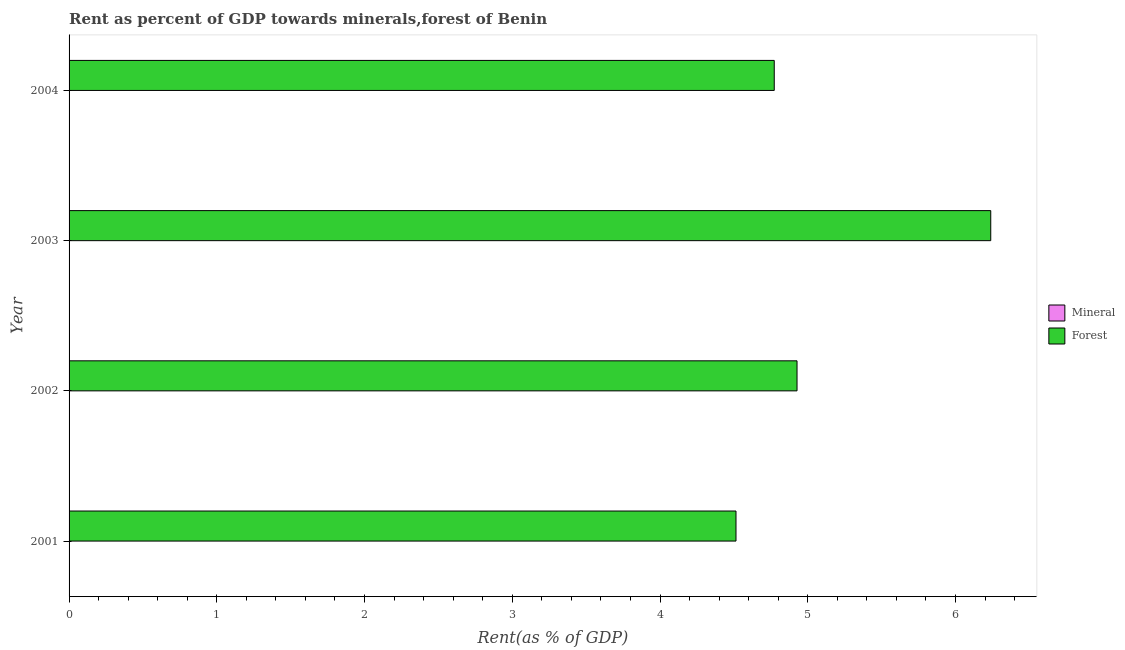How many groups of bars are there?
Provide a succinct answer. 4. Are the number of bars on each tick of the Y-axis equal?
Make the answer very short. Yes. How many bars are there on the 4th tick from the top?
Keep it short and to the point. 2. What is the label of the 2nd group of bars from the top?
Offer a very short reply. 2003. In how many cases, is the number of bars for a given year not equal to the number of legend labels?
Offer a very short reply. 0. What is the forest rent in 2004?
Your response must be concise. 4.77. Across all years, what is the maximum mineral rent?
Provide a succinct answer. 0. Across all years, what is the minimum mineral rent?
Your response must be concise. 0. In which year was the forest rent minimum?
Provide a short and direct response. 2001. What is the total forest rent in the graph?
Your response must be concise. 20.45. What is the difference between the mineral rent in 2001 and the forest rent in 2002?
Your answer should be very brief. -4.93. What is the average forest rent per year?
Provide a succinct answer. 5.11. In the year 2002, what is the difference between the forest rent and mineral rent?
Your answer should be very brief. 4.93. In how many years, is the mineral rent greater than 2 %?
Keep it short and to the point. 0. What is the ratio of the mineral rent in 2001 to that in 2004?
Your answer should be very brief. 0.07. In how many years, is the mineral rent greater than the average mineral rent taken over all years?
Your response must be concise. 2. What does the 2nd bar from the top in 2002 represents?
Your answer should be very brief. Mineral. What does the 1st bar from the bottom in 2003 represents?
Your response must be concise. Mineral. How many bars are there?
Provide a succinct answer. 8. Does the graph contain any zero values?
Give a very brief answer. No. Does the graph contain grids?
Provide a short and direct response. No. Where does the legend appear in the graph?
Offer a very short reply. Center right. What is the title of the graph?
Offer a terse response. Rent as percent of GDP towards minerals,forest of Benin. What is the label or title of the X-axis?
Make the answer very short. Rent(as % of GDP). What is the Rent(as % of GDP) of Mineral in 2001?
Your response must be concise. 0. What is the Rent(as % of GDP) of Forest in 2001?
Make the answer very short. 4.51. What is the Rent(as % of GDP) of Mineral in 2002?
Provide a succinct answer. 0. What is the Rent(as % of GDP) of Forest in 2002?
Offer a very short reply. 4.93. What is the Rent(as % of GDP) in Mineral in 2003?
Ensure brevity in your answer.  0. What is the Rent(as % of GDP) of Forest in 2003?
Your response must be concise. 6.24. What is the Rent(as % of GDP) of Mineral in 2004?
Offer a terse response. 0. What is the Rent(as % of GDP) in Forest in 2004?
Provide a succinct answer. 4.77. Across all years, what is the maximum Rent(as % of GDP) in Mineral?
Offer a very short reply. 0. Across all years, what is the maximum Rent(as % of GDP) of Forest?
Provide a short and direct response. 6.24. Across all years, what is the minimum Rent(as % of GDP) of Mineral?
Your answer should be very brief. 0. Across all years, what is the minimum Rent(as % of GDP) of Forest?
Your answer should be very brief. 4.51. What is the total Rent(as % of GDP) in Mineral in the graph?
Ensure brevity in your answer.  0. What is the total Rent(as % of GDP) of Forest in the graph?
Offer a terse response. 20.45. What is the difference between the Rent(as % of GDP) of Mineral in 2001 and that in 2002?
Ensure brevity in your answer.  -0. What is the difference between the Rent(as % of GDP) in Forest in 2001 and that in 2002?
Make the answer very short. -0.41. What is the difference between the Rent(as % of GDP) of Mineral in 2001 and that in 2003?
Offer a very short reply. -0. What is the difference between the Rent(as % of GDP) in Forest in 2001 and that in 2003?
Offer a terse response. -1.72. What is the difference between the Rent(as % of GDP) of Mineral in 2001 and that in 2004?
Offer a very short reply. -0. What is the difference between the Rent(as % of GDP) of Forest in 2001 and that in 2004?
Keep it short and to the point. -0.26. What is the difference between the Rent(as % of GDP) of Mineral in 2002 and that in 2003?
Your answer should be compact. -0. What is the difference between the Rent(as % of GDP) in Forest in 2002 and that in 2003?
Your response must be concise. -1.31. What is the difference between the Rent(as % of GDP) in Mineral in 2002 and that in 2004?
Make the answer very short. -0. What is the difference between the Rent(as % of GDP) in Forest in 2002 and that in 2004?
Offer a very short reply. 0.15. What is the difference between the Rent(as % of GDP) in Mineral in 2003 and that in 2004?
Offer a very short reply. -0. What is the difference between the Rent(as % of GDP) in Forest in 2003 and that in 2004?
Make the answer very short. 1.47. What is the difference between the Rent(as % of GDP) of Mineral in 2001 and the Rent(as % of GDP) of Forest in 2002?
Make the answer very short. -4.93. What is the difference between the Rent(as % of GDP) in Mineral in 2001 and the Rent(as % of GDP) in Forest in 2003?
Your answer should be very brief. -6.24. What is the difference between the Rent(as % of GDP) of Mineral in 2001 and the Rent(as % of GDP) of Forest in 2004?
Give a very brief answer. -4.77. What is the difference between the Rent(as % of GDP) of Mineral in 2002 and the Rent(as % of GDP) of Forest in 2003?
Ensure brevity in your answer.  -6.24. What is the difference between the Rent(as % of GDP) of Mineral in 2002 and the Rent(as % of GDP) of Forest in 2004?
Make the answer very short. -4.77. What is the difference between the Rent(as % of GDP) in Mineral in 2003 and the Rent(as % of GDP) in Forest in 2004?
Give a very brief answer. -4.77. What is the average Rent(as % of GDP) in Mineral per year?
Keep it short and to the point. 0. What is the average Rent(as % of GDP) of Forest per year?
Offer a terse response. 5.11. In the year 2001, what is the difference between the Rent(as % of GDP) of Mineral and Rent(as % of GDP) of Forest?
Provide a short and direct response. -4.51. In the year 2002, what is the difference between the Rent(as % of GDP) of Mineral and Rent(as % of GDP) of Forest?
Keep it short and to the point. -4.93. In the year 2003, what is the difference between the Rent(as % of GDP) in Mineral and Rent(as % of GDP) in Forest?
Your answer should be compact. -6.24. In the year 2004, what is the difference between the Rent(as % of GDP) in Mineral and Rent(as % of GDP) in Forest?
Offer a very short reply. -4.77. What is the ratio of the Rent(as % of GDP) of Mineral in 2001 to that in 2002?
Your answer should be compact. 0.11. What is the ratio of the Rent(as % of GDP) in Forest in 2001 to that in 2002?
Offer a terse response. 0.92. What is the ratio of the Rent(as % of GDP) of Mineral in 2001 to that in 2003?
Provide a short and direct response. 0.07. What is the ratio of the Rent(as % of GDP) of Forest in 2001 to that in 2003?
Provide a short and direct response. 0.72. What is the ratio of the Rent(as % of GDP) of Mineral in 2001 to that in 2004?
Keep it short and to the point. 0.07. What is the ratio of the Rent(as % of GDP) of Forest in 2001 to that in 2004?
Your answer should be compact. 0.95. What is the ratio of the Rent(as % of GDP) in Mineral in 2002 to that in 2003?
Your answer should be compact. 0.69. What is the ratio of the Rent(as % of GDP) in Forest in 2002 to that in 2003?
Provide a succinct answer. 0.79. What is the ratio of the Rent(as % of GDP) of Mineral in 2002 to that in 2004?
Offer a terse response. 0.6. What is the ratio of the Rent(as % of GDP) of Forest in 2002 to that in 2004?
Ensure brevity in your answer.  1.03. What is the ratio of the Rent(as % of GDP) in Mineral in 2003 to that in 2004?
Your answer should be compact. 0.87. What is the ratio of the Rent(as % of GDP) in Forest in 2003 to that in 2004?
Offer a terse response. 1.31. What is the difference between the highest and the second highest Rent(as % of GDP) in Mineral?
Your answer should be compact. 0. What is the difference between the highest and the second highest Rent(as % of GDP) of Forest?
Offer a terse response. 1.31. What is the difference between the highest and the lowest Rent(as % of GDP) of Mineral?
Your response must be concise. 0. What is the difference between the highest and the lowest Rent(as % of GDP) in Forest?
Your answer should be very brief. 1.72. 